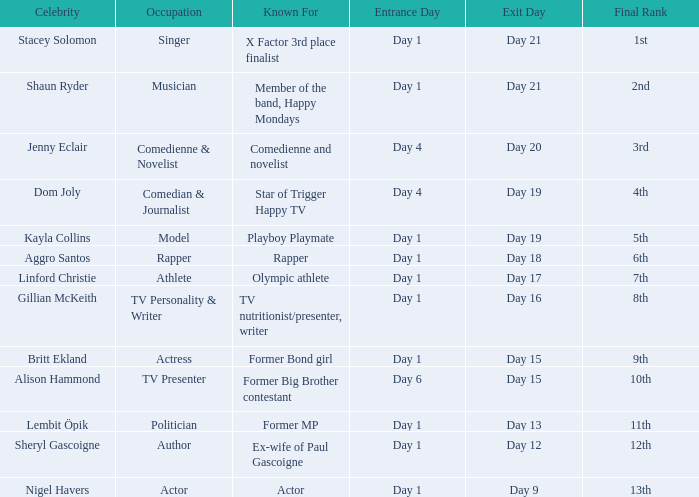What position did the celebrity finish that entered on day 1 and exited on day 19? 5th. Could you parse the entire table? {'header': ['Celebrity', 'Occupation', 'Known For', 'Entrance Day', 'Exit Day', 'Final Rank'], 'rows': [['Stacey Solomon', 'Singer', 'X Factor 3rd place finalist', 'Day 1', 'Day 21', '1st'], ['Shaun Ryder', 'Musician', 'Member of the band, Happy Mondays', 'Day 1', 'Day 21', '2nd'], ['Jenny Eclair', 'Comedienne & Novelist', 'Comedienne and novelist', 'Day 4', 'Day 20', '3rd'], ['Dom Joly', 'Comedian & Journalist', 'Star of Trigger Happy TV', 'Day 4', 'Day 19', '4th'], ['Kayla Collins', 'Model', 'Playboy Playmate', 'Day 1', 'Day 19', '5th'], ['Aggro Santos', 'Rapper', 'Rapper', 'Day 1', 'Day 18', '6th'], ['Linford Christie', 'Athlete', 'Olympic athlete', 'Day 1', 'Day 17', '7th'], ['Gillian McKeith', 'TV Personality & Writer', 'TV nutritionist/presenter, writer', 'Day 1', 'Day 16', '8th'], ['Britt Ekland', 'Actress', 'Former Bond girl', 'Day 1', 'Day 15', '9th'], ['Alison Hammond', 'TV Presenter', 'Former Big Brother contestant', 'Day 6', 'Day 15', '10th'], ['Lembit Öpik', 'Politician', 'Former MP', 'Day 1', 'Day 13', '11th'], ['Sheryl Gascoigne', 'Author', 'Ex-wife of Paul Gascoigne', 'Day 1', 'Day 12', '12th'], ['Nigel Havers', 'Actor', 'Actor', 'Day 1', 'Day 9', '13th']]} 